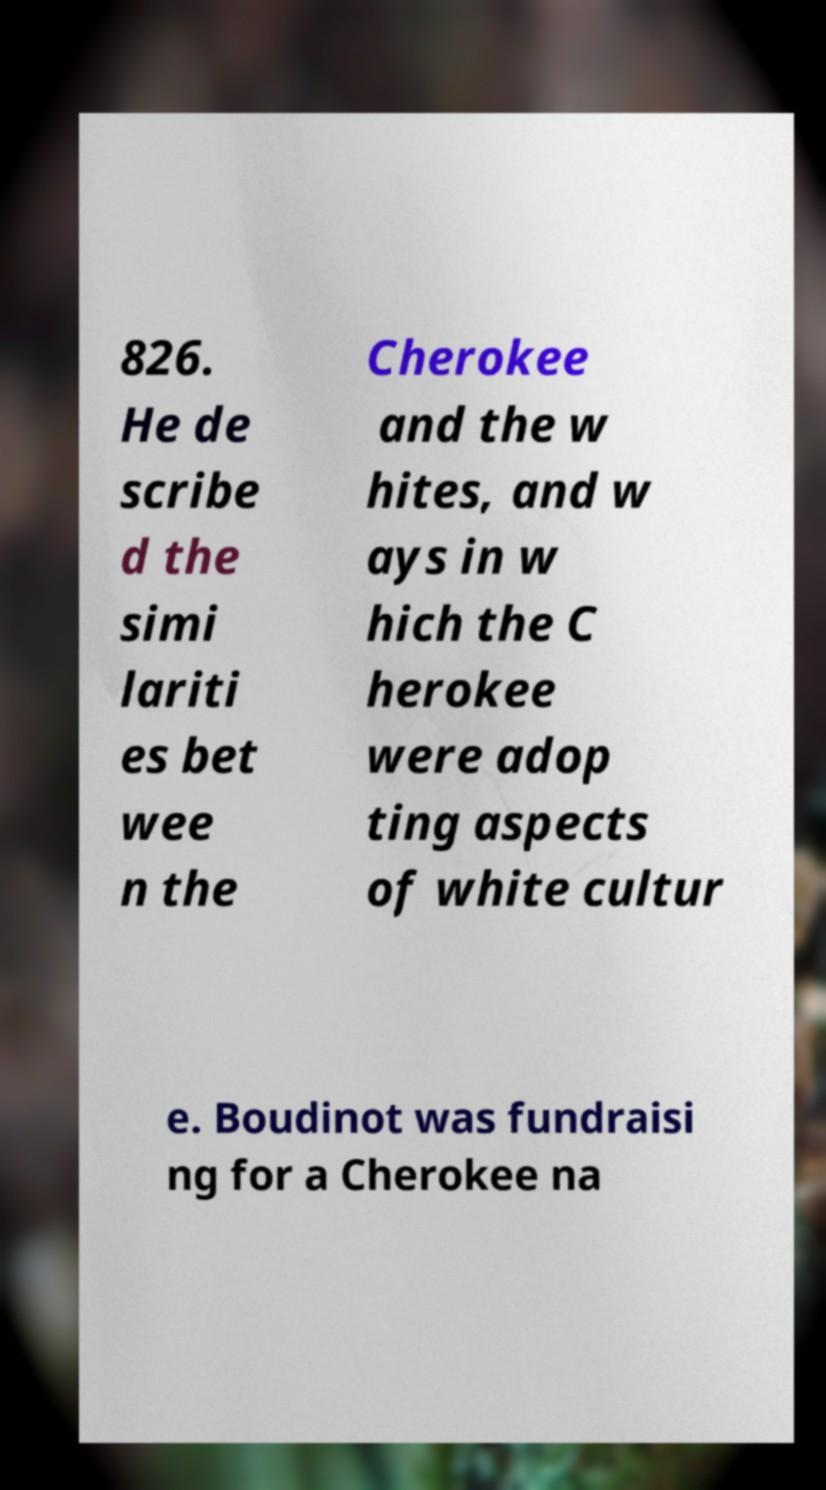Can you accurately transcribe the text from the provided image for me? 826. He de scribe d the simi lariti es bet wee n the Cherokee and the w hites, and w ays in w hich the C herokee were adop ting aspects of white cultur e. Boudinot was fundraisi ng for a Cherokee na 